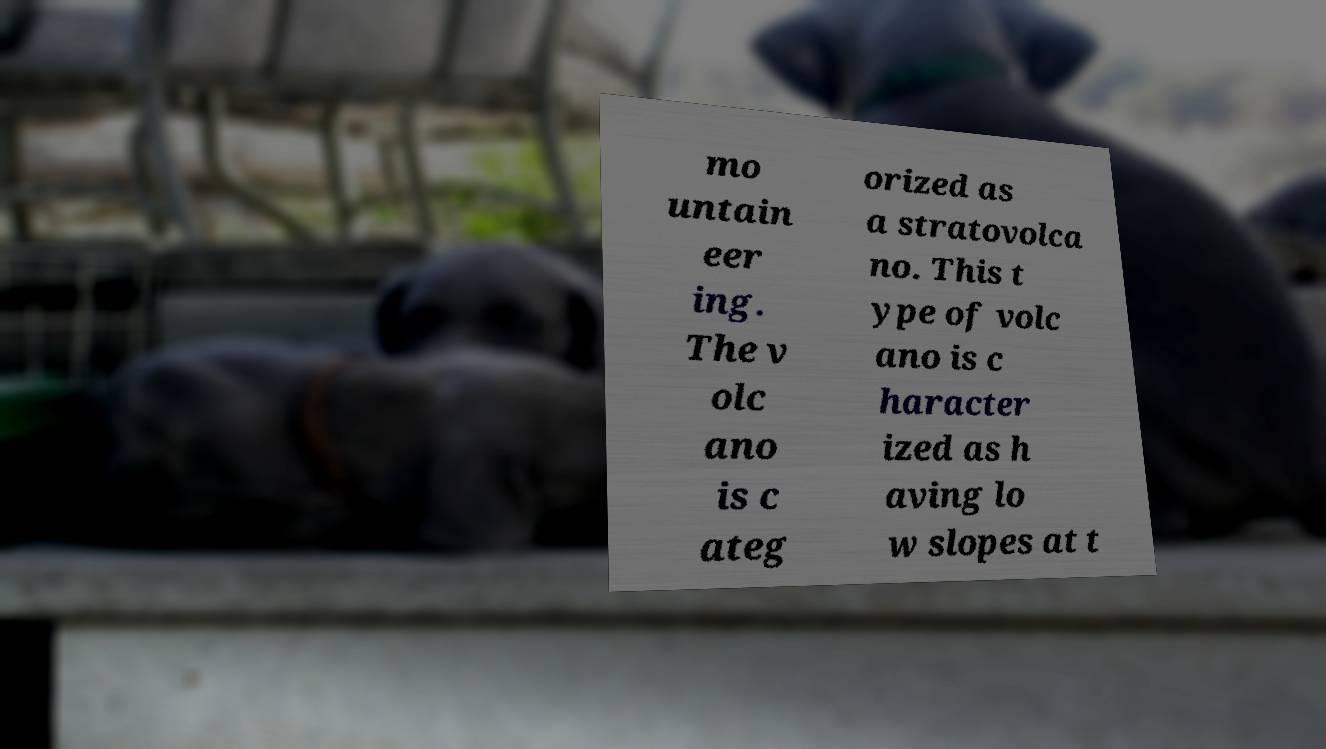Could you extract and type out the text from this image? mo untain eer ing. The v olc ano is c ateg orized as a stratovolca no. This t ype of volc ano is c haracter ized as h aving lo w slopes at t 